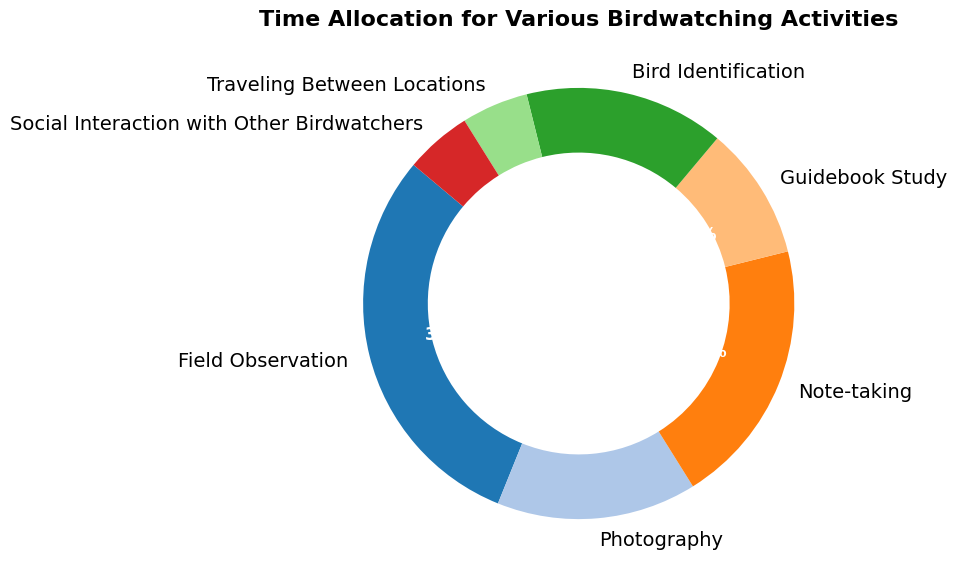What's the activity with the highest percentage? By observing the pie chart, you can see the activity with the largest slice/segment of the pie chart. The largest segment represents the activity with the highest percentage.
Answer: Field Observation What is the combined percentage of Photography and Bird Identification? Add the percentage values for Photography (15%) and Bird Identification (15%). 15% + 15% = 30%
Answer: 30% Which activities share the same percentage of time allocation? Look for segments with the same size and percentage labels. Both Photography and Bird Identification have a percentage of 15%. Social Interaction with Other Birdwatchers and Traveling Between Locations both have a percentage of 5%.
Answer: Photography and Bird Identification; Social Interaction with Other Birdwatchers and Traveling Between Locations What's the percentage difference between Field Observation and Traveling Between Locations? Subtract the smaller percentage (5% for Traveling Between Locations) from the larger percentage (30% for Field Observation). 30% - 5% = 25%
Answer: 25% How much greater is the time spent on Note-taking compared to Guidebook Study? Subtract the percentage for Guidebook Study (10%) from the percentage for Note-taking (20%). 20% - 10% = 10%
Answer: 10% What's the total time allocation for Field Observation, Note-taking, and Bird Identification? Add the percentages for Field Observation (30%), Note-taking (20%), and Bird Identification (15%). 30% + 20% + 15% = 65%
Answer: 65% What is the smallest percentage value shown, and which activity does it represent? Identify the activity with the smallest segment in the pie chart. Both Social Interaction with Other Birdwatchers and Traveling Between Locations have the smallest percentage, which is 5%.
Answer: 5%, Social Interaction with Other Birdwatchers and Traveling Between Locations How much more time is spent on Photography compared to Social Interaction with Other Birdwatchers? Subtract the percentage for Social Interaction with Other Birdwatchers (5%) from the percentage for Photography (15%). 15% - 5% = 10%
Answer: 10% 